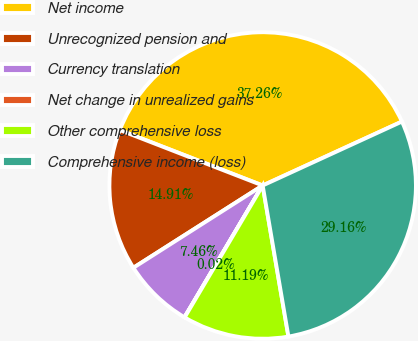Convert chart. <chart><loc_0><loc_0><loc_500><loc_500><pie_chart><fcel>Net income<fcel>Unrecognized pension and<fcel>Currency translation<fcel>Net change in unrealized gains<fcel>Other comprehensive loss<fcel>Comprehensive income (loss)<nl><fcel>37.26%<fcel>14.91%<fcel>7.46%<fcel>0.02%<fcel>11.19%<fcel>29.16%<nl></chart> 